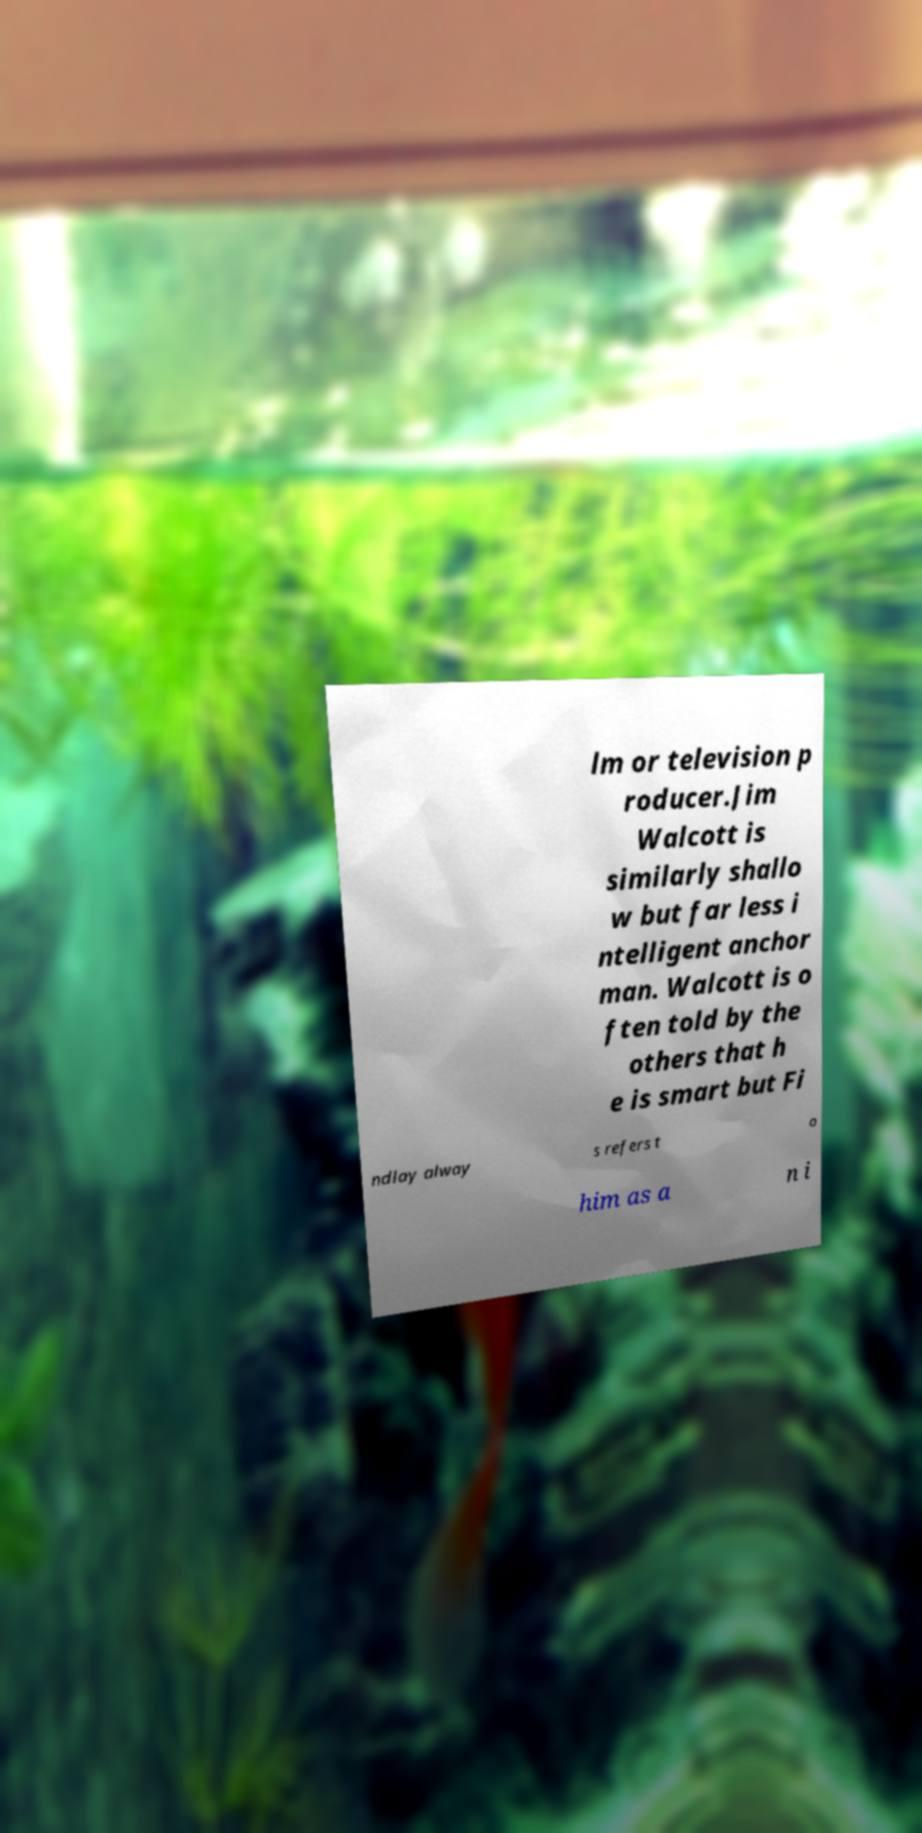Can you accurately transcribe the text from the provided image for me? lm or television p roducer.Jim Walcott is similarly shallo w but far less i ntelligent anchor man. Walcott is o ften told by the others that h e is smart but Fi ndlay alway s refers t o him as a n i 